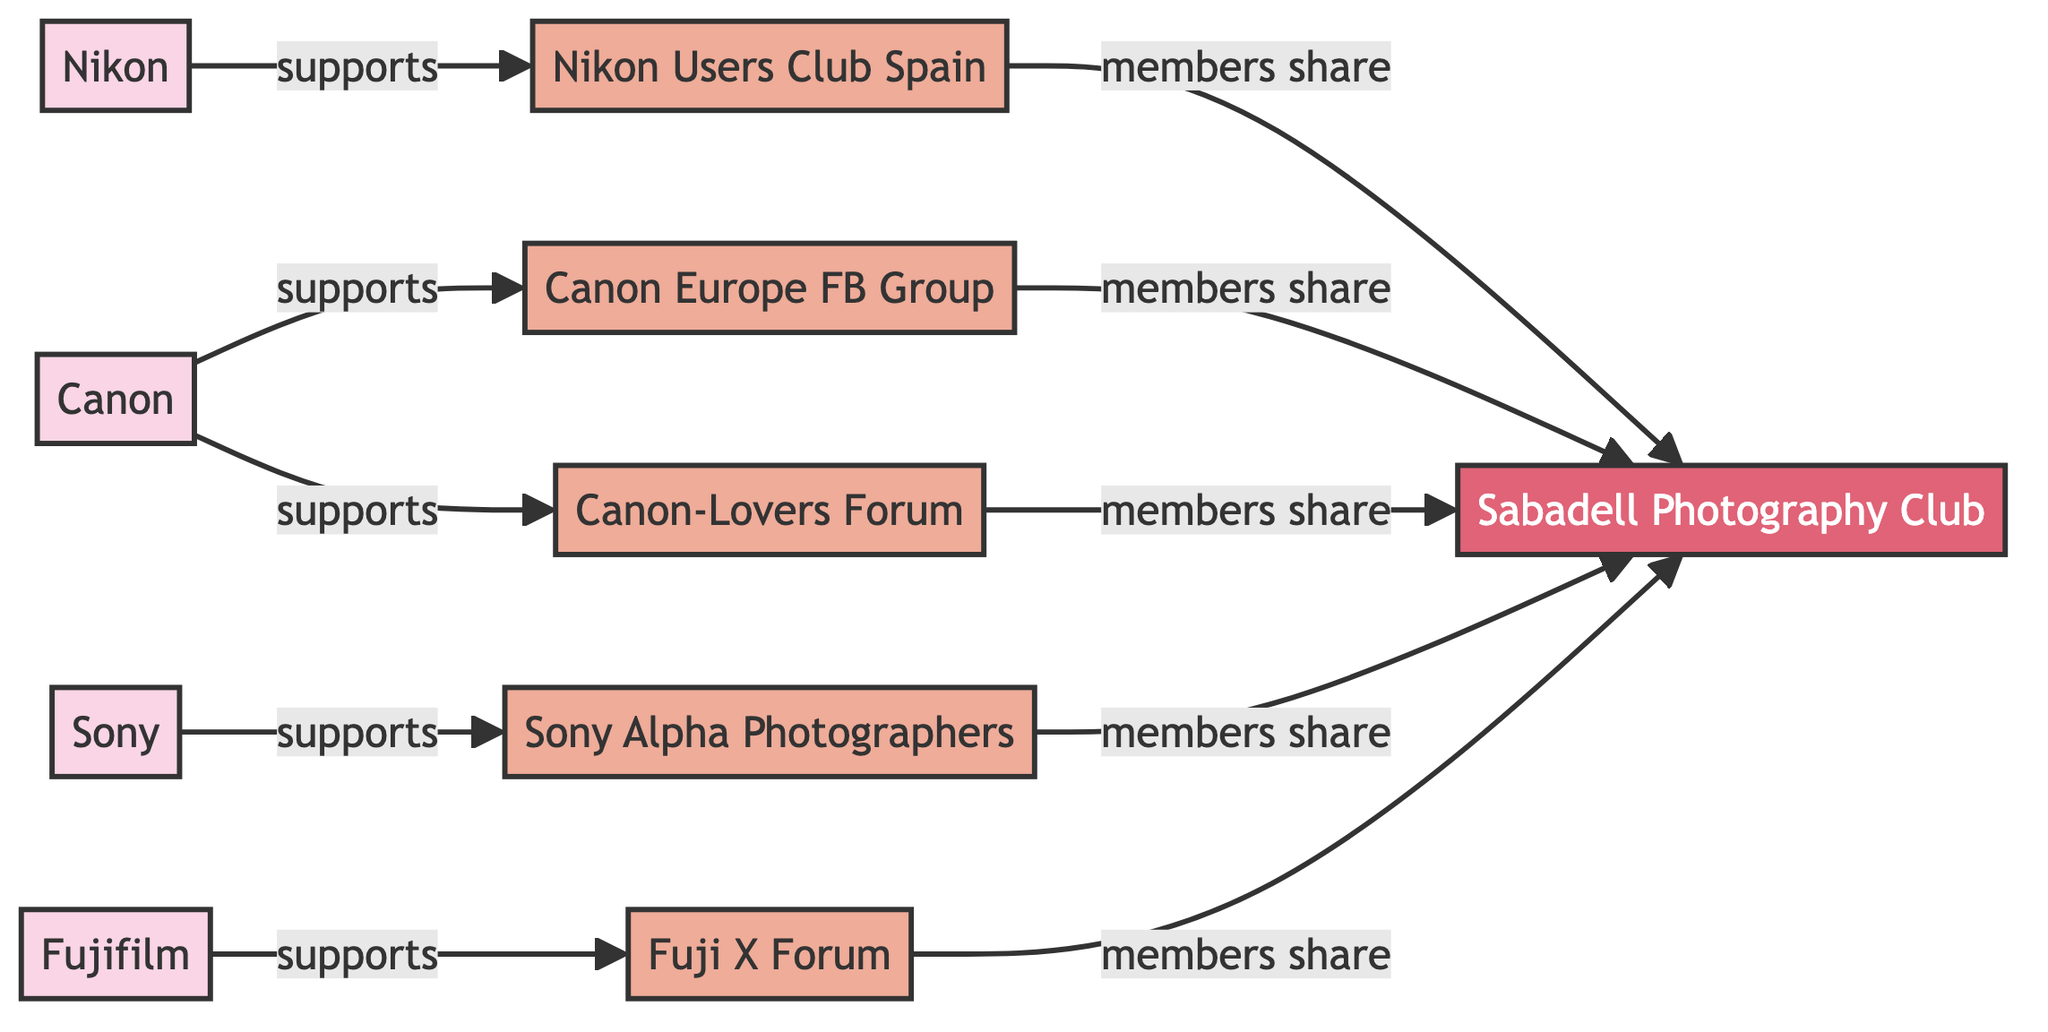What is the total number of camera brands in the diagram? The diagram lists four distinct camera brands: Canon, Nikon, Sony, and Fujifilm. Therefore, by counting the unique brand nodes, we find that there are a total of four camera brands represented in the diagram.
Answer: 4 Which community is directly supported by Canon? According to the diagram, Canon has two direct edges leading to communities: Canon Europe Facebook Group and Canon-Lovers Forum. By checking the relationships, we see that Canon directly supports both of these communities. However, the question seeks only one, so we can say that one community supported by Canon is the Canon Europe Facebook Group.
Answer: Canon Europe Facebook Group How many communities share members with the Sabadell Photography Club? The diagram shows that the Sabadell Photography Club has five connections from different communities, indicating that five communities have members who share with it. By counting these connections, we determine there are five communities that share members with the Sabadell Photography Club.
Answer: 5 Which brand supports the Sony Alpha Photographers community? The diagram shows that Sony is the only brand that supports the Sony Alpha Photographers community. By looking at the edges, we see that there's a direct connection from the Sony node to the Sony Alpha Photographers community.
Answer: Sony Identify all the relationships between the communities and the Sabadell Photography Club. The diagram indicates that the following communities have a relationship with the Sabadell Photography Club: Canon Europe Facebook Group, Nikon Users Club Spain, Sony Alpha Photographers, Fuji X Forum, and Canon-Lovers Forum. Each of these communities shares members with Sabadell Photography Club. Thus, there are five relationships that connect these communities to the local photography club.
Answer: 5 relationships Which brand appears most frequently in support of communities? Upon examining the diagram, we note that Canon supports two communities: Canon Europe Facebook Group and Canon-Lovers Forum. The other brands support one community each. Therefore, Canon has the most connections, making it the brand that appears most frequently in support of communities.
Answer: Canon How many edges are connected to the brands besides Fujifilm? The diagram displays that Canon has two edges, Nikon has one edge, and Sony has one edge, while Fujifilm has one edge but isn’t counted in this inquiry. Thus, adding the edges from Canon, Nikon, and Sony, we find that there are four edges connected to these brands.
Answer: 4 Name a brand that supports the Nikon Users Club Spain. The diagram explicitly indicates that Nikon supports the Nikon Users Club Spain through a direct relationship. Therefore, the answer is simply Nikon since it is the only brand associated with this community.
Answer: Nikon 